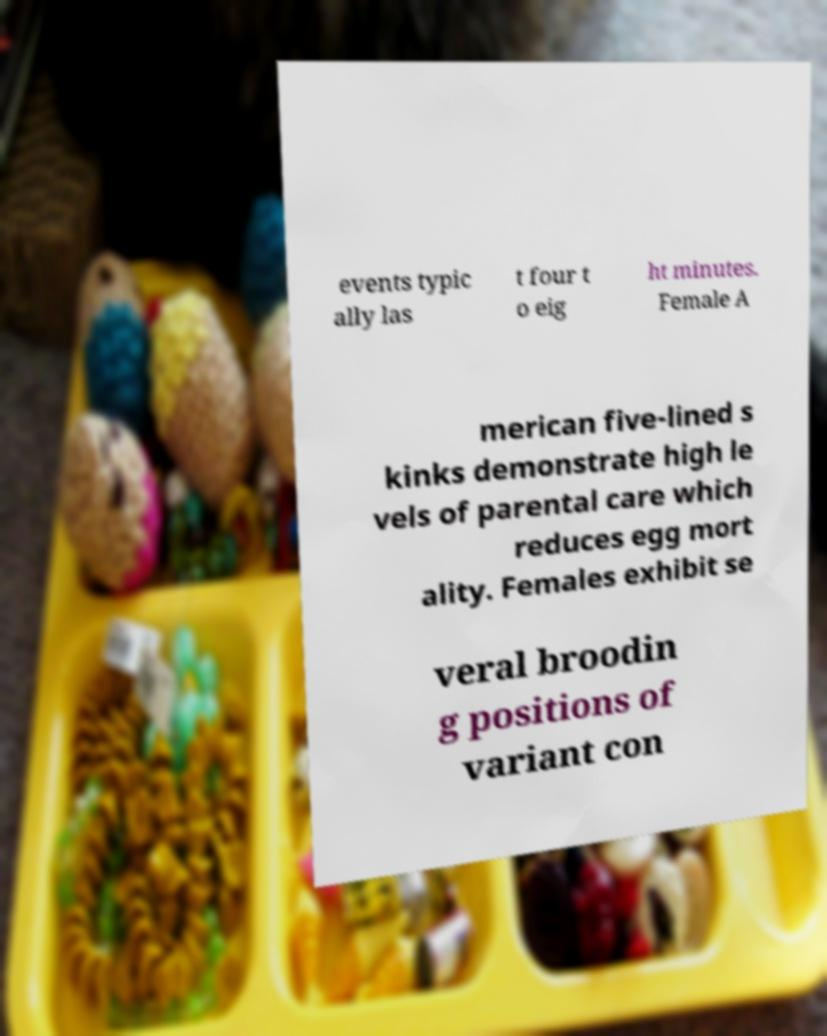Please read and relay the text visible in this image. What does it say? events typic ally las t four t o eig ht minutes. Female A merican five-lined s kinks demonstrate high le vels of parental care which reduces egg mort ality. Females exhibit se veral broodin g positions of variant con 